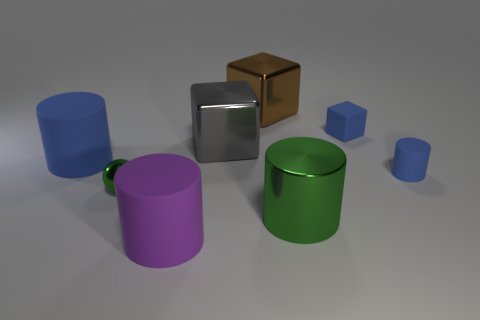There is a big thing to the right of the large brown block on the left side of the matte thing that is behind the big gray object; what is its color?
Offer a very short reply. Green. How many other things are there of the same color as the sphere?
Your answer should be very brief. 1. Are there fewer large gray rubber spheres than green shiny things?
Keep it short and to the point. Yes. There is a big cylinder that is to the right of the small green thing and behind the purple cylinder; what is its color?
Make the answer very short. Green. There is a small blue object that is the same shape as the big blue rubber object; what is its material?
Your answer should be compact. Rubber. Are there more tiny rubber cubes than blue matte things?
Your response must be concise. No. There is a cylinder that is on the left side of the blue block and behind the green cylinder; what is its size?
Make the answer very short. Large. The small green object is what shape?
Offer a terse response. Sphere. How many tiny things are the same shape as the large green object?
Offer a terse response. 1. Are there fewer blue cubes left of the large gray thing than blue matte cylinders left of the tiny rubber cylinder?
Offer a very short reply. Yes. 